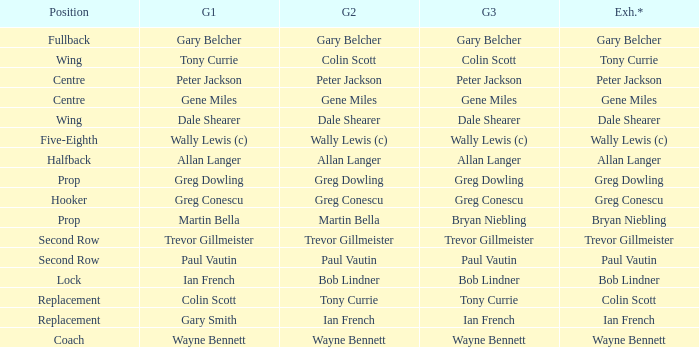Wjat game 3 has ian french as a game of 2? Ian French. 